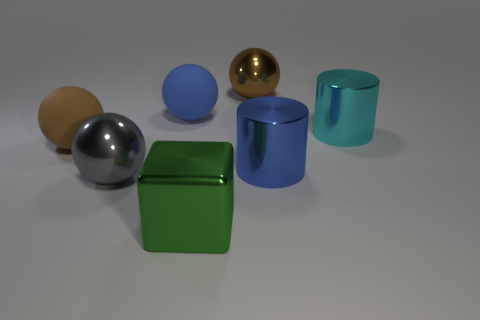Subtract all brown rubber spheres. How many spheres are left? 3 Subtract 1 spheres. How many spheres are left? 3 Subtract all brown blocks. How many brown balls are left? 2 Add 2 brown metal spheres. How many objects exist? 9 Subtract all gray balls. How many balls are left? 3 Subtract all blocks. How many objects are left? 6 Subtract all gray spheres. Subtract all brown cubes. How many spheres are left? 3 Subtract all small yellow spheres. Subtract all brown things. How many objects are left? 5 Add 2 brown shiny things. How many brown shiny things are left? 3 Add 2 big green shiny blocks. How many big green shiny blocks exist? 3 